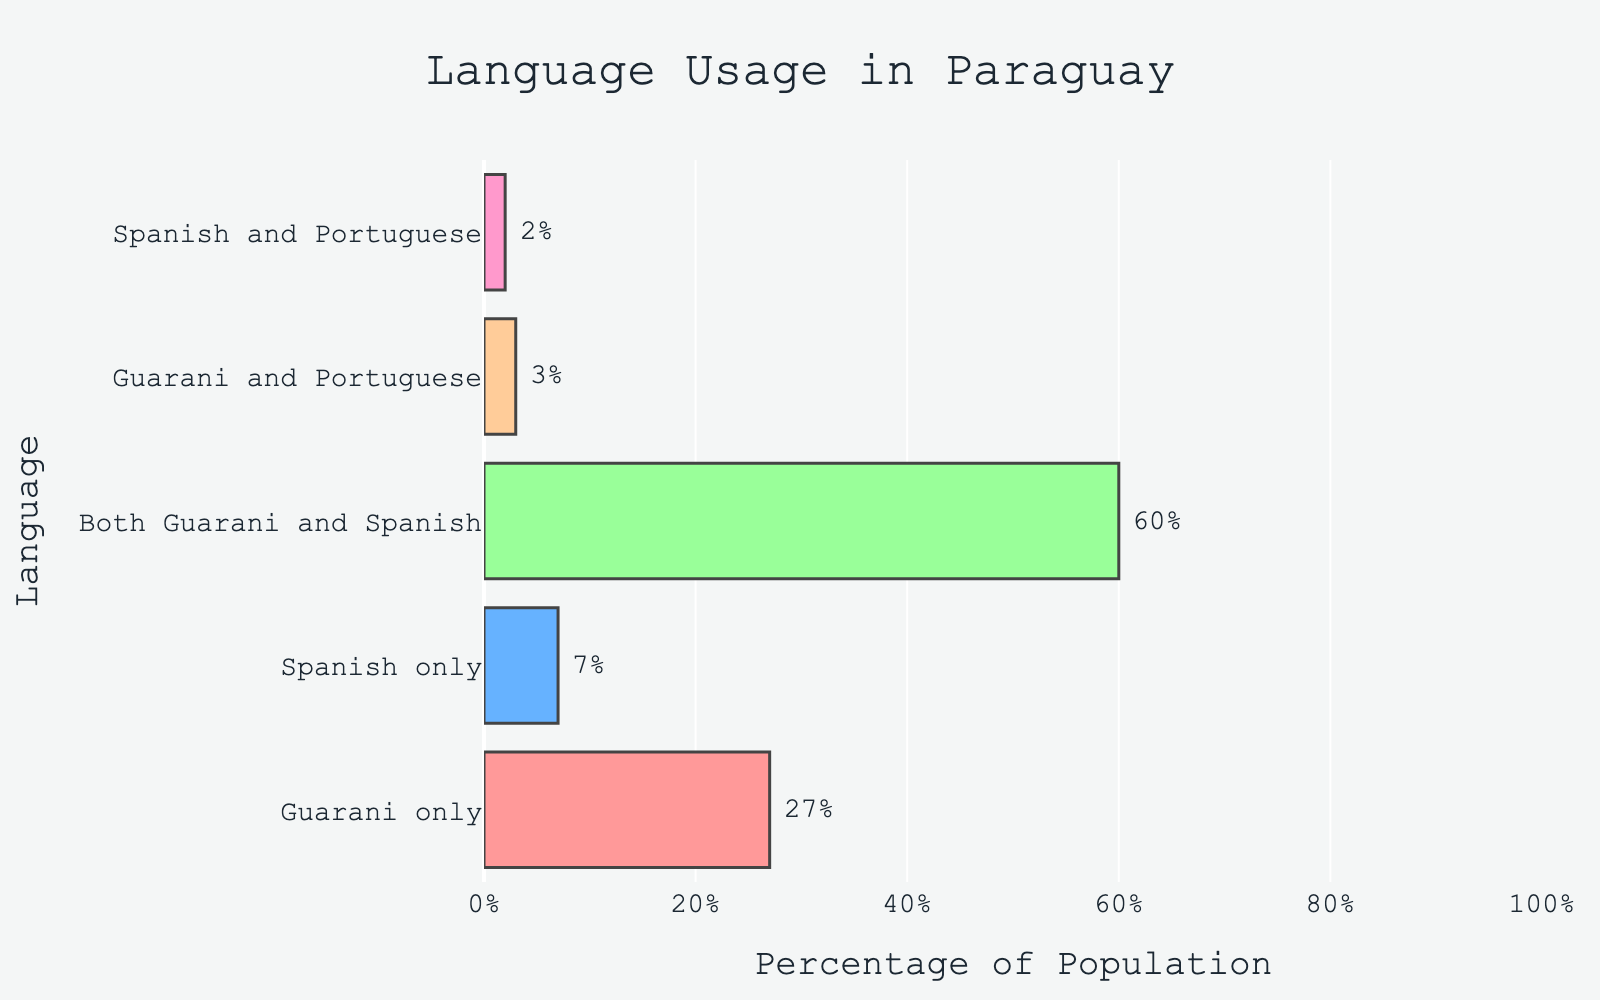Which language combination has the highest percentage of speakers? Observing the chart, the bar for "Both Guarani and Spanish" reaches the highest percentage.
Answer: Both Guarani and Spanish Which language combination has the lowest percentage of speakers? The bar representing "Spanish and Portuguese" is the shortest, indicating it has the lowest percentage.
Answer: Spanish and Portuguese How much more percentage speak both Guarani and Spanish compared to Spanish only? The percentage for both Guarani and Spanish is 60%. For Spanish only, it is 7%. The difference is 60% - 7% = 53%.
Answer: 53% What is the combined percentage of people who speak Guarani either only or in combination with another language? Add the percentages of "Guarani only" (27%), "Both Guarani and Spanish" (60%), and "Guarani and Portuguese" (3%). The total is 27% + 60% + 3% = 90%.
Answer: 90% Compare the percentage of Guarani only speakers to Spanish only speakers. Which is higher and by how much? Guarani only speakers are 27%. Spanish only speakers are 7%. The difference is 27% - 7% = 20%, with Guarani having the higher percentage.
Answer: Guarani by 20% Which language combination is represented by the green bar in the chart? The green bar corresponds to the "Both Guarani and Spanish" category.
Answer: Both Guarani and Spanish If you sum the percentages of people who speak languages involving Spanish (including combinations), what is the result? Add the percentages of "Spanish only" (7%), "Both Guarani and Spanish" (60%), and "Spanish and Portuguese" (2%). The total is 7% + 60% + 2% = 69%.
Answer: 69% Among the language categories, how does the combination of Guarani and Portuguese rank based on percentage? By comparing the lengths of the bars, "Guarani and Portuguese" ranks fourth in percentage.
Answer: Fourth What is the average percentage of all listed language groups? The percentages are 27%, 7%, 60%, 3%, and 2%. Sum these (27 + 7 + 60 + 3 + 2 = 99) and divide by the number of groups (5). The average is 99 / 5 = 19.8%.
Answer: 19.8% Which language account for a total percentage greater than 50% when considering all combinations involving it? Considering Guarani in "Guarani only" (27%), "Both Guarani and Spanish" (60%), and "Guarani and Portuguese" (3%), their sum is 27% + 60% + 3% = 90%, which is greater than 50%.
Answer: Guarani 